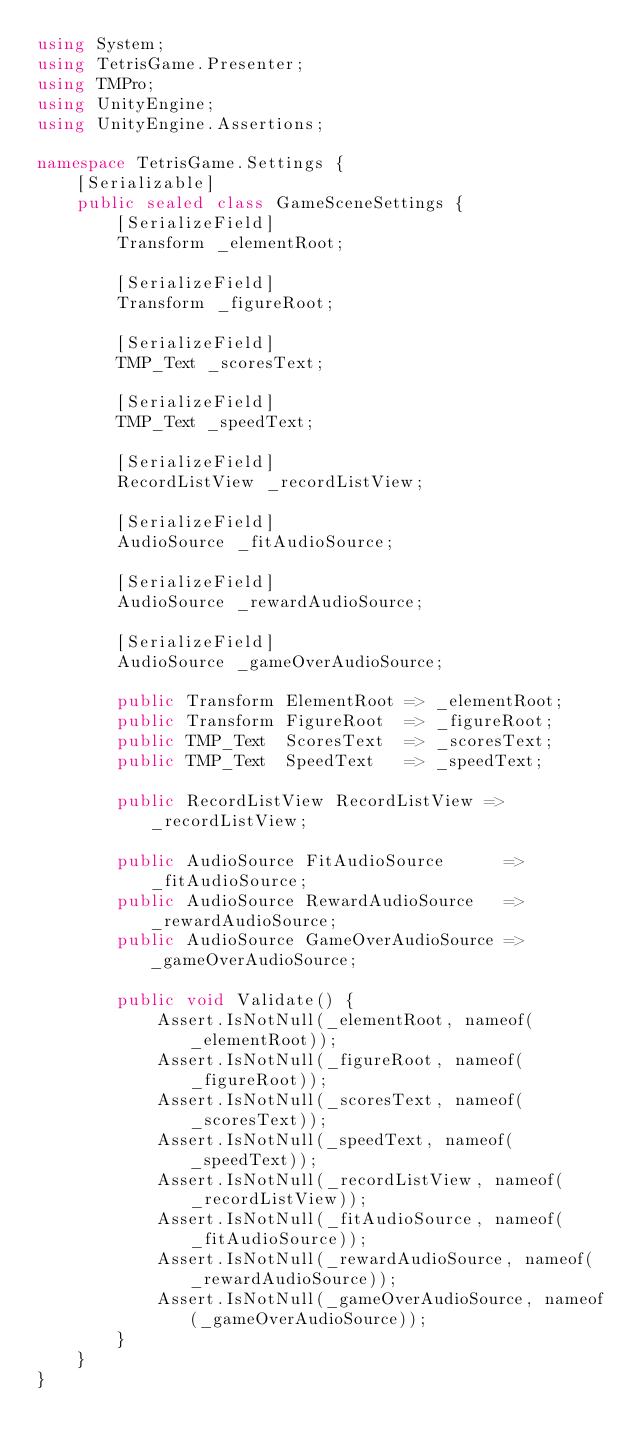<code> <loc_0><loc_0><loc_500><loc_500><_C#_>using System;
using TetrisGame.Presenter;
using TMPro;
using UnityEngine;
using UnityEngine.Assertions;

namespace TetrisGame.Settings {
	[Serializable]
	public sealed class GameSceneSettings {
		[SerializeField]
		Transform _elementRoot;

		[SerializeField]
		Transform _figureRoot;

		[SerializeField]
		TMP_Text _scoresText;

		[SerializeField]
		TMP_Text _speedText;

		[SerializeField]
		RecordListView _recordListView;

		[SerializeField]
		AudioSource _fitAudioSource;

		[SerializeField]
		AudioSource _rewardAudioSource;

		[SerializeField]
		AudioSource _gameOverAudioSource;

		public Transform ElementRoot => _elementRoot;
		public Transform FigureRoot  => _figureRoot;
		public TMP_Text  ScoresText  => _scoresText;
		public TMP_Text  SpeedText   => _speedText;

		public RecordListView RecordListView => _recordListView;

		public AudioSource FitAudioSource      => _fitAudioSource;
		public AudioSource RewardAudioSource   => _rewardAudioSource;
		public AudioSource GameOverAudioSource => _gameOverAudioSource;

		public void Validate() {
			Assert.IsNotNull(_elementRoot, nameof(_elementRoot));
			Assert.IsNotNull(_figureRoot, nameof(_figureRoot));
			Assert.IsNotNull(_scoresText, nameof(_scoresText));
			Assert.IsNotNull(_speedText, nameof(_speedText));
			Assert.IsNotNull(_recordListView, nameof(_recordListView));
			Assert.IsNotNull(_fitAudioSource, nameof(_fitAudioSource));
			Assert.IsNotNull(_rewardAudioSource, nameof(_rewardAudioSource));
			Assert.IsNotNull(_gameOverAudioSource, nameof(_gameOverAudioSource));
		}
	}
}</code> 